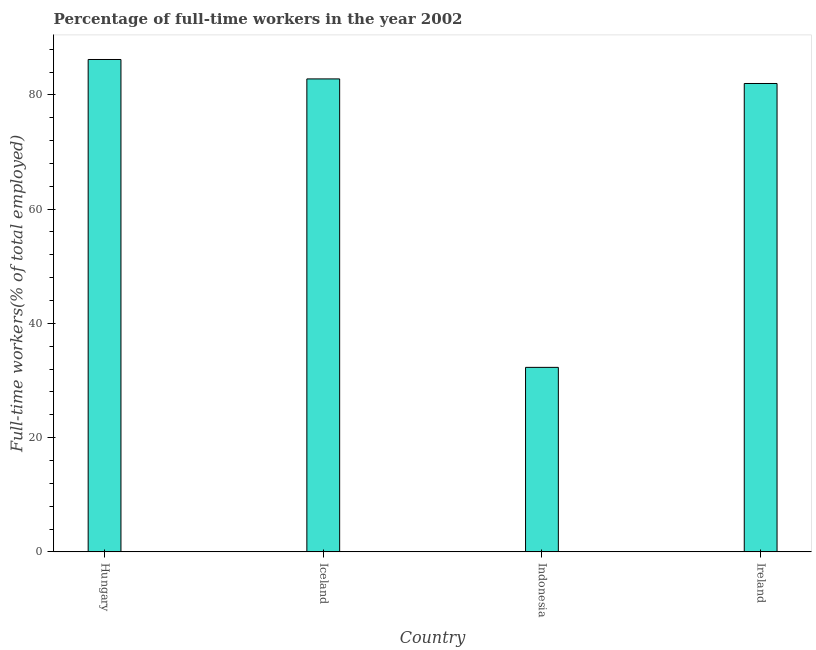Does the graph contain any zero values?
Offer a very short reply. No. Does the graph contain grids?
Ensure brevity in your answer.  No. What is the title of the graph?
Make the answer very short. Percentage of full-time workers in the year 2002. What is the label or title of the X-axis?
Your response must be concise. Country. What is the label or title of the Y-axis?
Keep it short and to the point. Full-time workers(% of total employed). What is the percentage of full-time workers in Iceland?
Offer a very short reply. 82.8. Across all countries, what is the maximum percentage of full-time workers?
Provide a short and direct response. 86.2. Across all countries, what is the minimum percentage of full-time workers?
Offer a very short reply. 32.3. In which country was the percentage of full-time workers maximum?
Offer a very short reply. Hungary. What is the sum of the percentage of full-time workers?
Your answer should be compact. 283.3. What is the difference between the percentage of full-time workers in Iceland and Indonesia?
Your answer should be compact. 50.5. What is the average percentage of full-time workers per country?
Provide a short and direct response. 70.83. What is the median percentage of full-time workers?
Keep it short and to the point. 82.4. What is the ratio of the percentage of full-time workers in Iceland to that in Indonesia?
Ensure brevity in your answer.  2.56. What is the difference between the highest and the second highest percentage of full-time workers?
Your answer should be very brief. 3.4. Is the sum of the percentage of full-time workers in Hungary and Iceland greater than the maximum percentage of full-time workers across all countries?
Offer a terse response. Yes. What is the difference between the highest and the lowest percentage of full-time workers?
Keep it short and to the point. 53.9. How many bars are there?
Ensure brevity in your answer.  4. Are all the bars in the graph horizontal?
Your answer should be compact. No. How many countries are there in the graph?
Ensure brevity in your answer.  4. What is the difference between two consecutive major ticks on the Y-axis?
Ensure brevity in your answer.  20. What is the Full-time workers(% of total employed) of Hungary?
Offer a very short reply. 86.2. What is the Full-time workers(% of total employed) of Iceland?
Offer a very short reply. 82.8. What is the Full-time workers(% of total employed) in Indonesia?
Your response must be concise. 32.3. What is the difference between the Full-time workers(% of total employed) in Hungary and Iceland?
Provide a short and direct response. 3.4. What is the difference between the Full-time workers(% of total employed) in Hungary and Indonesia?
Your response must be concise. 53.9. What is the difference between the Full-time workers(% of total employed) in Iceland and Indonesia?
Offer a terse response. 50.5. What is the difference between the Full-time workers(% of total employed) in Indonesia and Ireland?
Keep it short and to the point. -49.7. What is the ratio of the Full-time workers(% of total employed) in Hungary to that in Iceland?
Your response must be concise. 1.04. What is the ratio of the Full-time workers(% of total employed) in Hungary to that in Indonesia?
Ensure brevity in your answer.  2.67. What is the ratio of the Full-time workers(% of total employed) in Hungary to that in Ireland?
Your answer should be very brief. 1.05. What is the ratio of the Full-time workers(% of total employed) in Iceland to that in Indonesia?
Ensure brevity in your answer.  2.56. What is the ratio of the Full-time workers(% of total employed) in Indonesia to that in Ireland?
Ensure brevity in your answer.  0.39. 